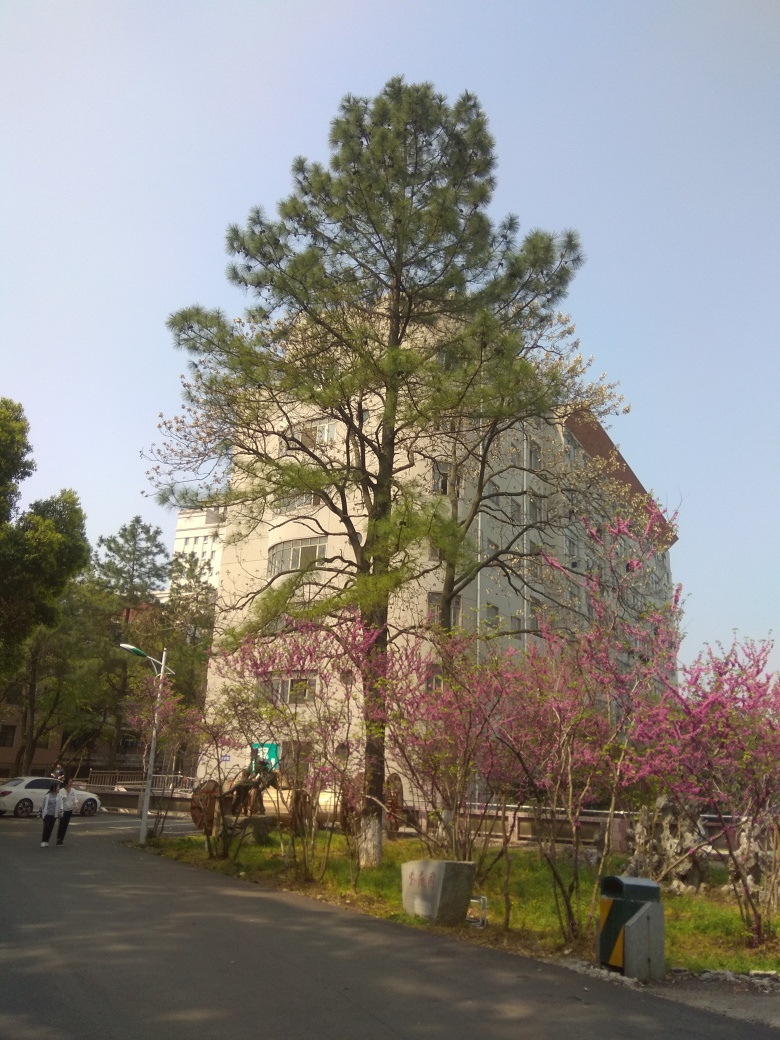What type of building is shown in the background? The building in the background has a modern architectural style, with large, regularly spaced windows and an overall cubic structure. It's not possible to determine its specific use from the image alone, but its design suggests it could be an office building or educational facility. 